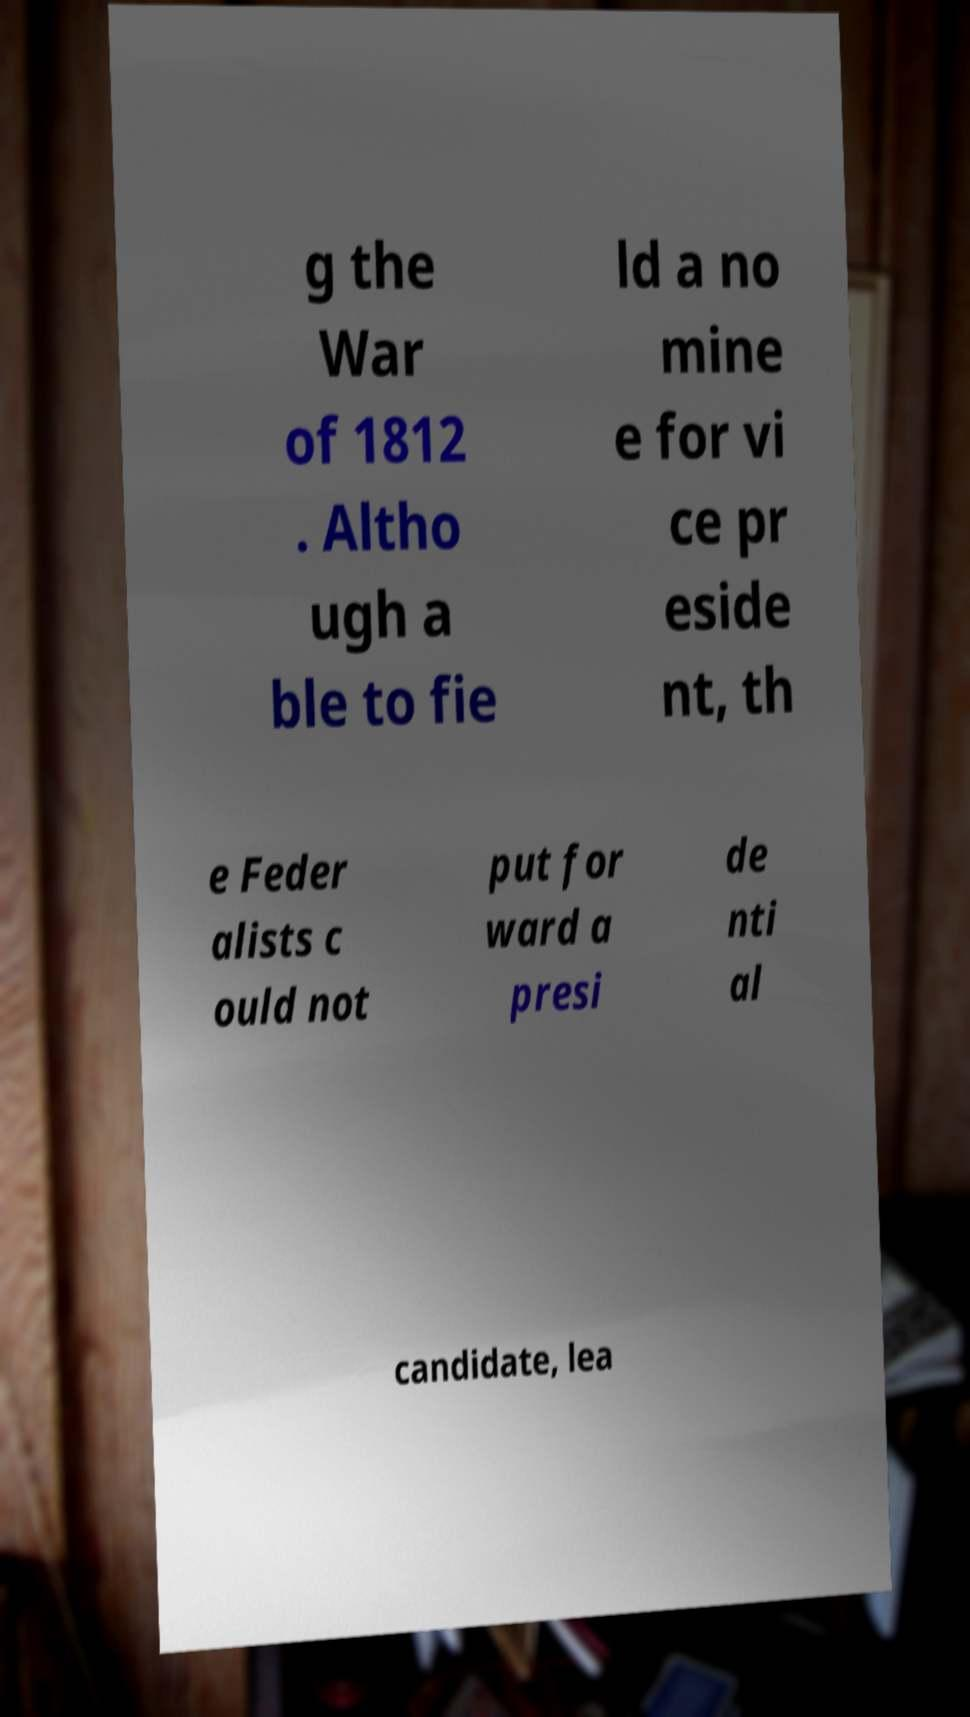Please read and relay the text visible in this image. What does it say? g the War of 1812 . Altho ugh a ble to fie ld a no mine e for vi ce pr eside nt, th e Feder alists c ould not put for ward a presi de nti al candidate, lea 